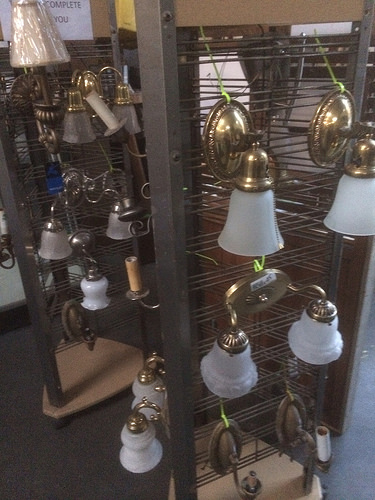<image>
Is there a bell in front of the bell? No. The bell is not in front of the bell. The spatial positioning shows a different relationship between these objects. 